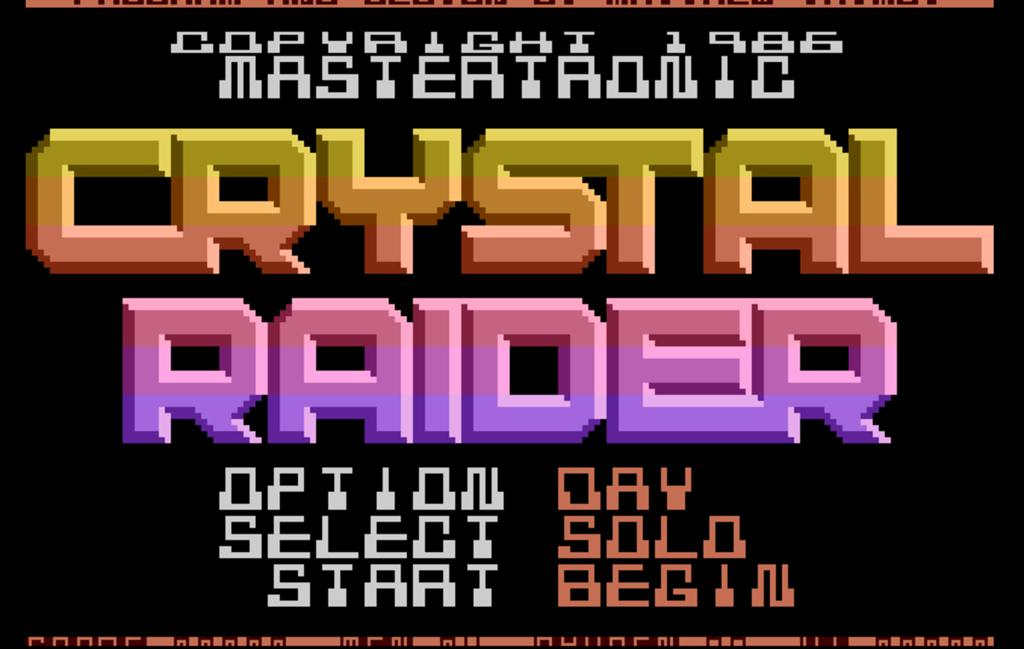<image>
Summarize the visual content of the image. The start screen of the game Crystal Raider offers different play options. 